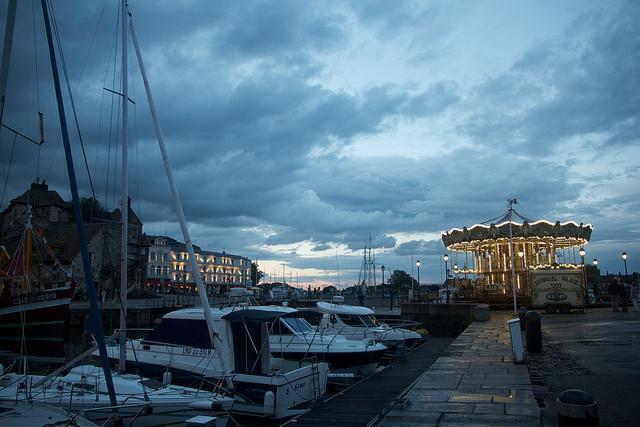What carved imagery animal is likely found on the amusement ride shown here?
Pick the right solution, then justify: 'Answer: answer
Rationale: rationale.'
Options: Horse, rabbits, dogs, cats. Answer: horse.
Rationale: The ride in the distance is a merry-go-round which has horses that go in circles. 